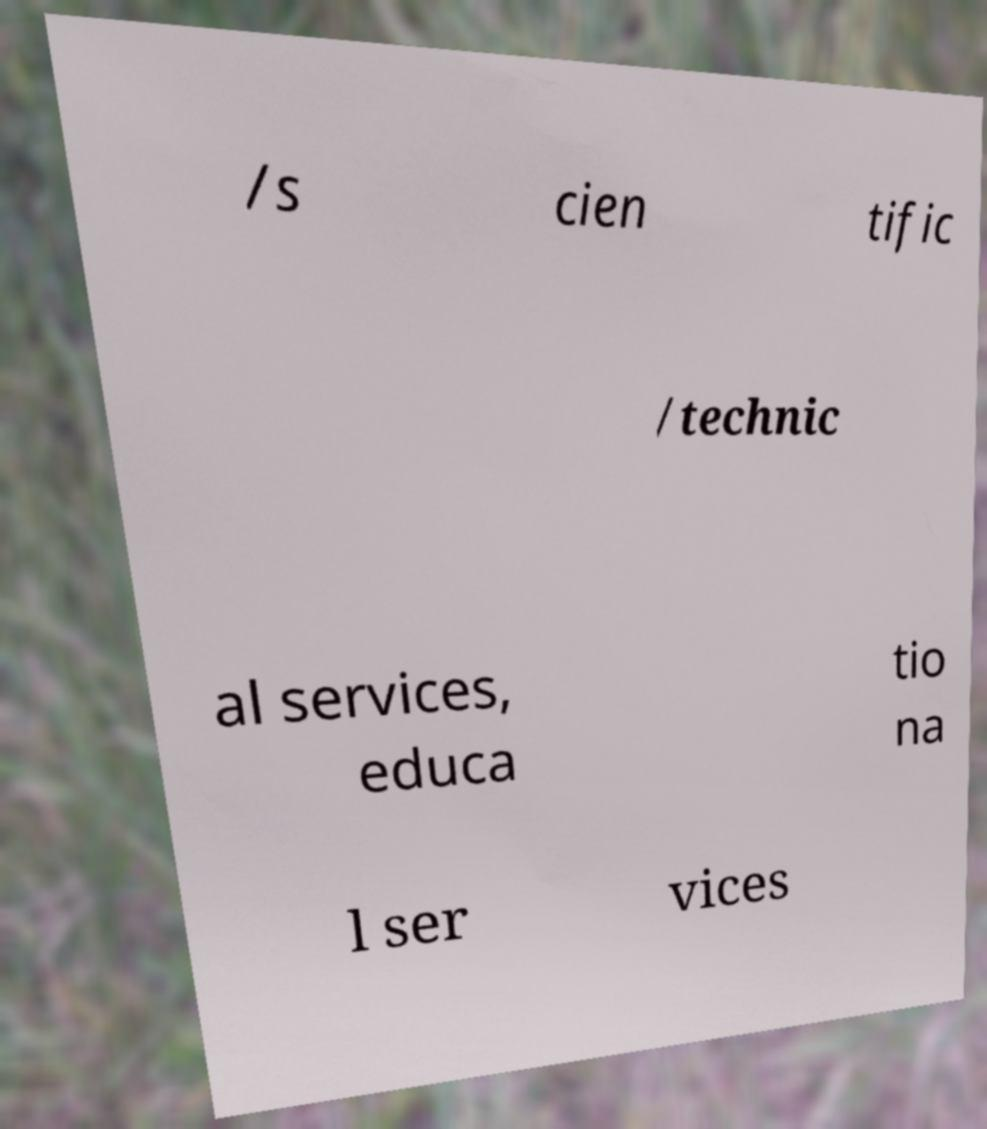There's text embedded in this image that I need extracted. Can you transcribe it verbatim? /s cien tific /technic al services, educa tio na l ser vices 